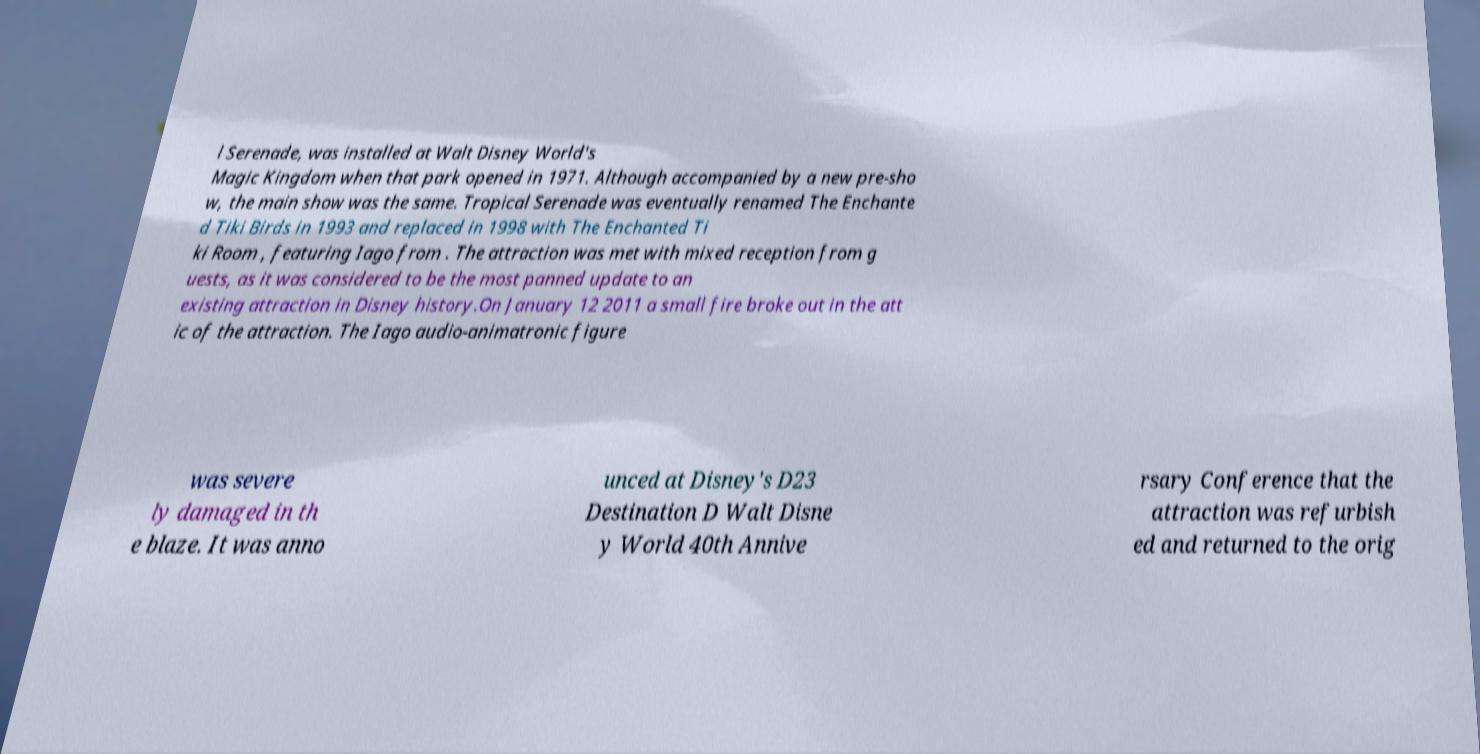Please read and relay the text visible in this image. What does it say? l Serenade, was installed at Walt Disney World's Magic Kingdom when that park opened in 1971. Although accompanied by a new pre-sho w, the main show was the same. Tropical Serenade was eventually renamed The Enchante d Tiki Birds in 1993 and replaced in 1998 with The Enchanted Ti ki Room , featuring Iago from . The attraction was met with mixed reception from g uests, as it was considered to be the most panned update to an existing attraction in Disney history.On January 12 2011 a small fire broke out in the att ic of the attraction. The Iago audio-animatronic figure was severe ly damaged in th e blaze. It was anno unced at Disney's D23 Destination D Walt Disne y World 40th Annive rsary Conference that the attraction was refurbish ed and returned to the orig 